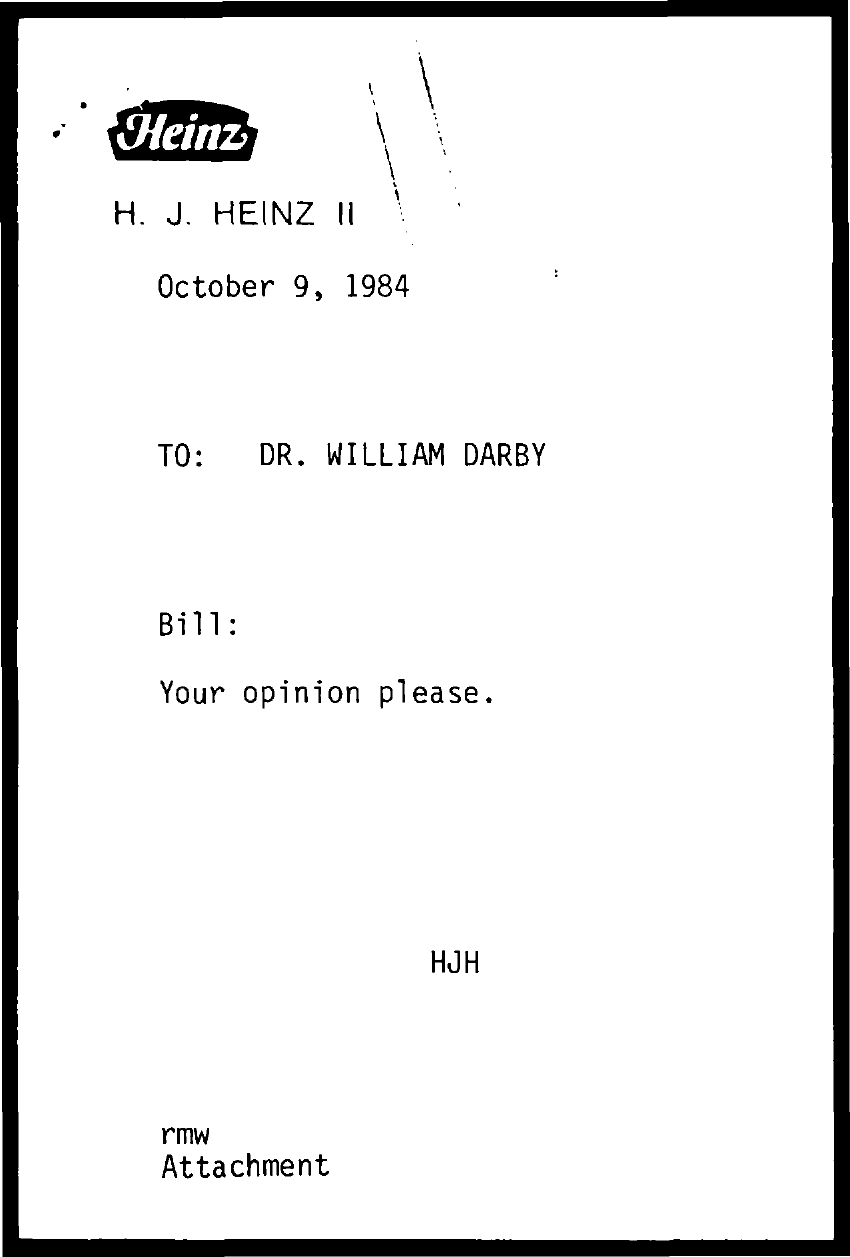Which company's name is mentioned?
Provide a succinct answer. Heinz. When is the document dated?
Your answer should be very brief. October 9, 1984. To whom is the note addressed?
Your response must be concise. Dr. William Darby. 